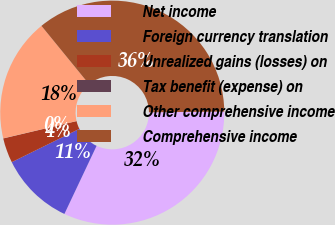Convert chart to OTSL. <chart><loc_0><loc_0><loc_500><loc_500><pie_chart><fcel>Net income<fcel>Foreign currency translation<fcel>Unrealized gains (losses) on<fcel>Tax benefit (expense) on<fcel>Other comprehensive income<fcel>Comprehensive income<nl><fcel>32.18%<fcel>10.69%<fcel>3.58%<fcel>0.02%<fcel>17.79%<fcel>35.74%<nl></chart> 